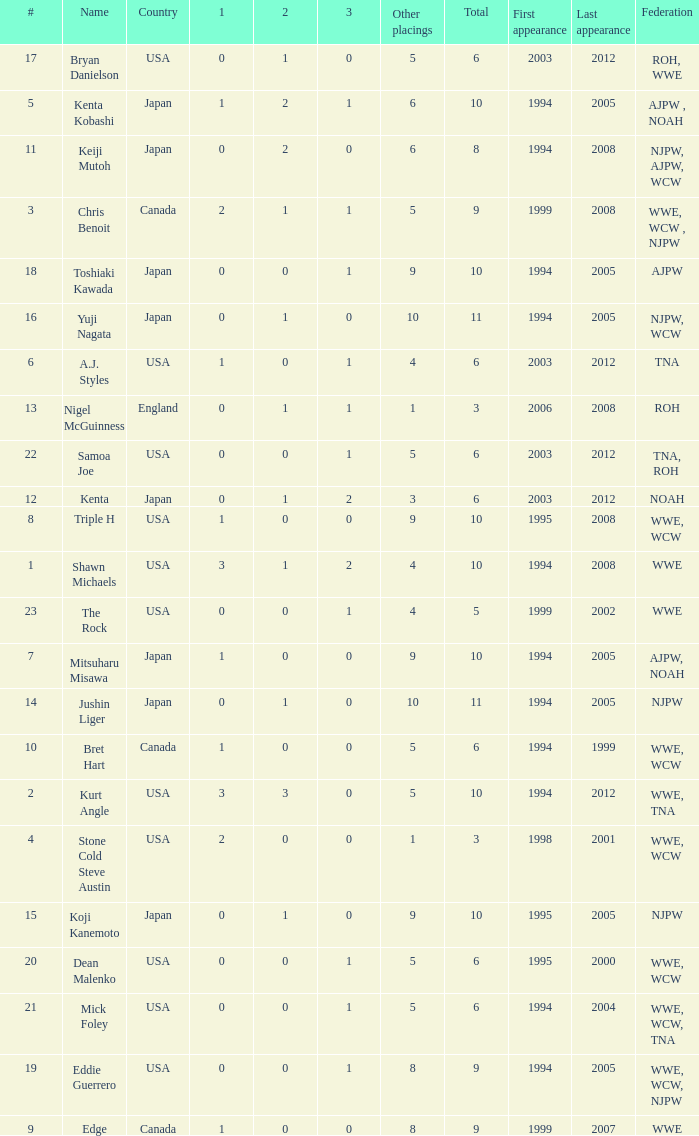What countries does the Rock come from? 1.0. 